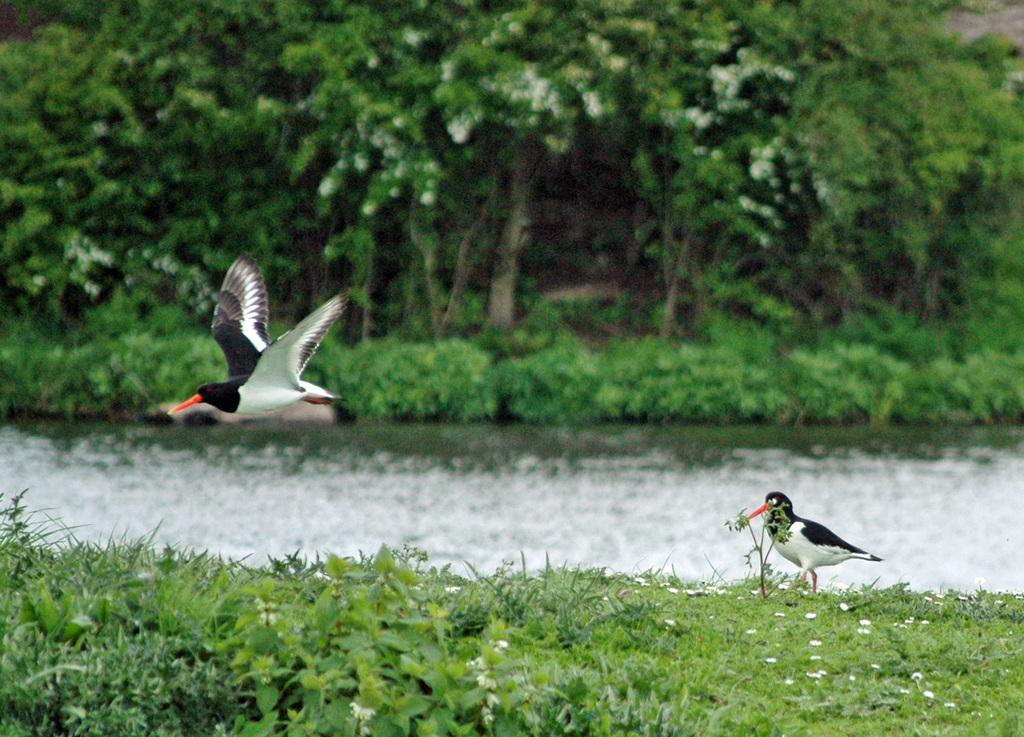What type of animals can be seen in the image? Birds can be seen in the image. What type of vegetation is present in the image? There is grass, plants, and trees visible in the image. What is the primary element visible in the image? Water is visible in the image. What can be seen in the background of the image? There are trees in the background of the image. What type of account is being managed by the secretary in the image? There is no secretary or account present in the image; it features birds, grass, plants, water, and trees. 